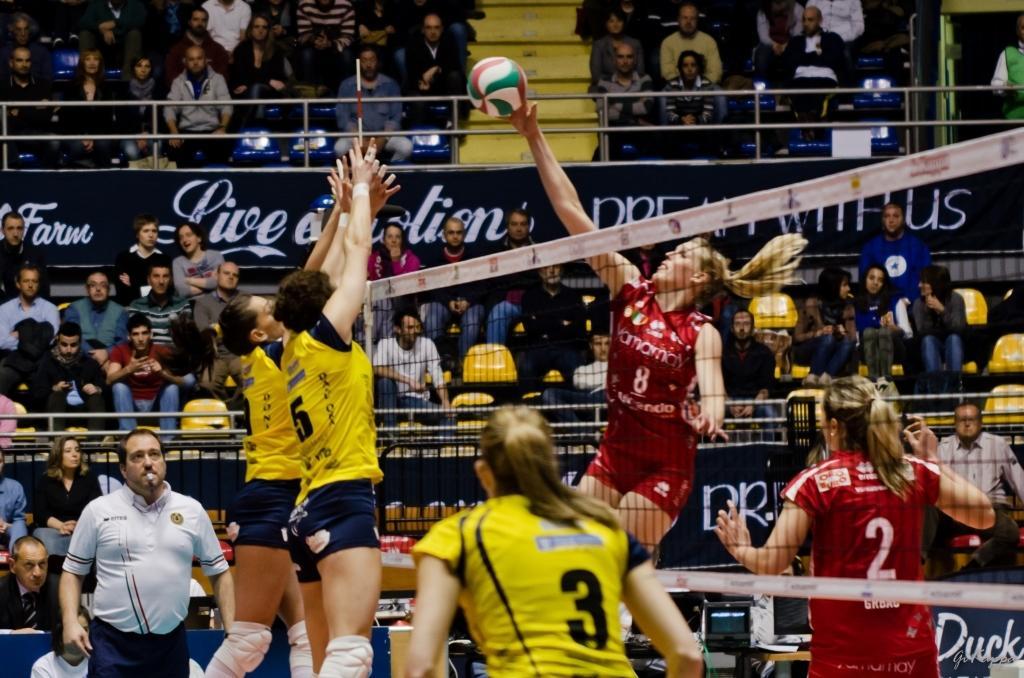In one or two sentences, can you explain what this image depicts? In this image there are group of audience sitting on the chairs, there is a board, there is text on the board, there is a ball, there are players playing volleyball, there is a net truncated towards the right of the image, there are person truncated towards the right of the right of the image, there are chairs truncated towards the right of the right of the image, there are person truncated towards the left of the image, there are person truncated towards the bottom of the image. 